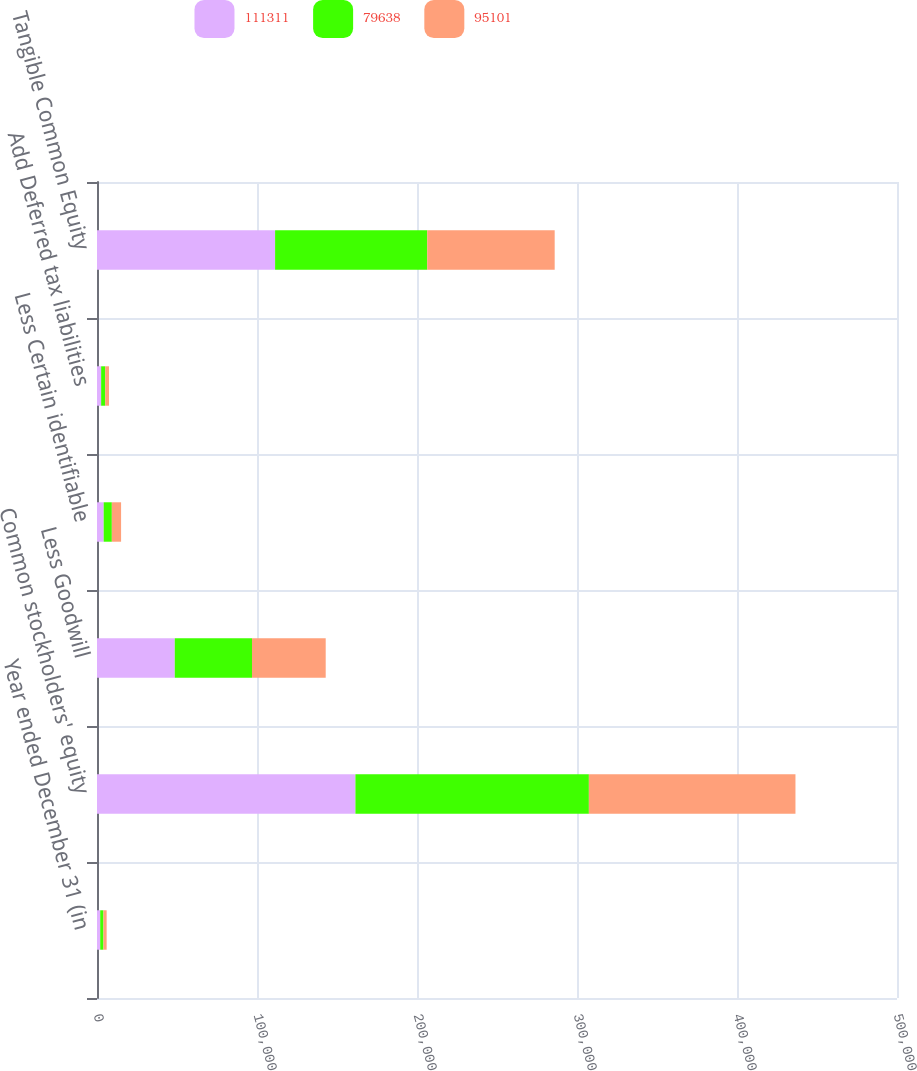<chart> <loc_0><loc_0><loc_500><loc_500><stacked_bar_chart><ecel><fcel>Year ended December 31 (in<fcel>Common stockholders' equity<fcel>Less Goodwill<fcel>Less Certain identifiable<fcel>Add Deferred tax liabilities<fcel>Tangible Common Equity<nl><fcel>111311<fcel>2010<fcel>161520<fcel>48618<fcel>4178<fcel>2587<fcel>111311<nl><fcel>79638<fcel>2009<fcel>145903<fcel>48254<fcel>5095<fcel>2547<fcel>95101<nl><fcel>95101<fcel>2008<fcel>129116<fcel>46068<fcel>5779<fcel>2369<fcel>79638<nl></chart> 